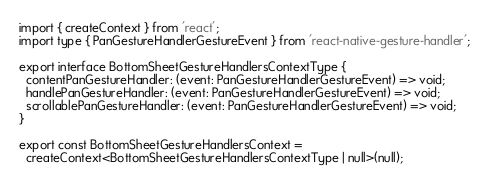<code> <loc_0><loc_0><loc_500><loc_500><_TypeScript_>import { createContext } from 'react';
import type { PanGestureHandlerGestureEvent } from 'react-native-gesture-handler';

export interface BottomSheetGestureHandlersContextType {
  contentPanGestureHandler: (event: PanGestureHandlerGestureEvent) => void;
  handlePanGestureHandler: (event: PanGestureHandlerGestureEvent) => void;
  scrollablePanGestureHandler: (event: PanGestureHandlerGestureEvent) => void;
}

export const BottomSheetGestureHandlersContext =
  createContext<BottomSheetGestureHandlersContextType | null>(null);
</code> 